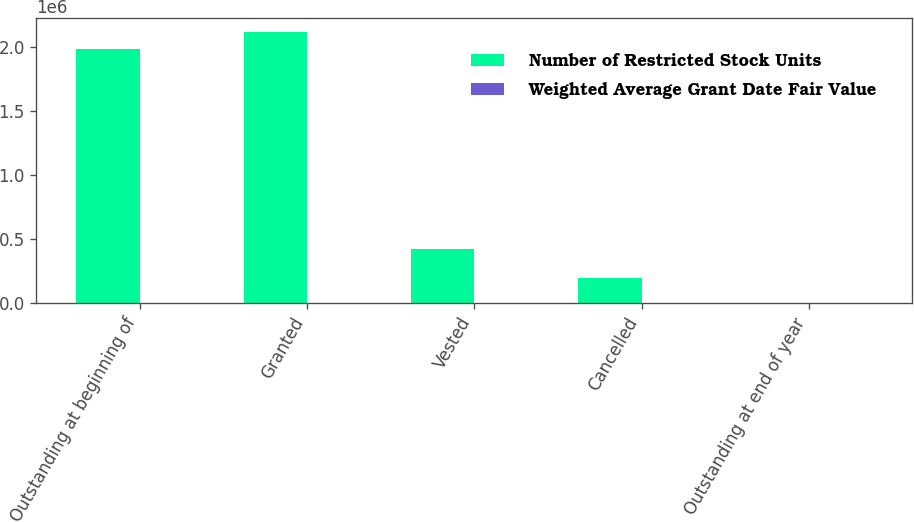<chart> <loc_0><loc_0><loc_500><loc_500><stacked_bar_chart><ecel><fcel>Outstanding at beginning of<fcel>Granted<fcel>Vested<fcel>Cancelled<fcel>Outstanding at end of year<nl><fcel>Number of Restricted Stock Units<fcel>1.97826e+06<fcel>2.11733e+06<fcel>423427<fcel>193932<fcel>25.6<nl><fcel>Weighted Average Grant Date Fair Value<fcel>25.6<fcel>23.14<fcel>25.57<fcel>25.05<fcel>24.12<nl></chart> 